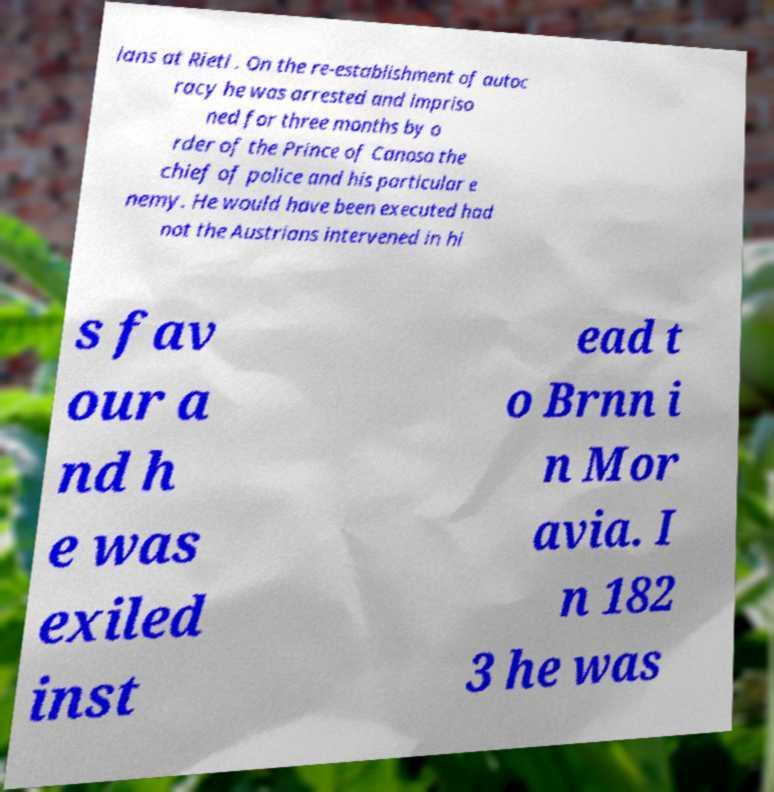There's text embedded in this image that I need extracted. Can you transcribe it verbatim? ians at Rieti . On the re-establishment of autoc racy he was arrested and impriso ned for three months by o rder of the Prince of Canosa the chief of police and his particular e nemy. He would have been executed had not the Austrians intervened in hi s fav our a nd h e was exiled inst ead t o Brnn i n Mor avia. I n 182 3 he was 